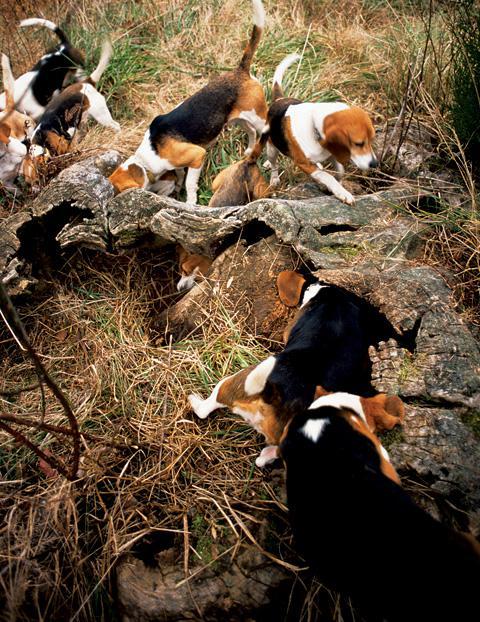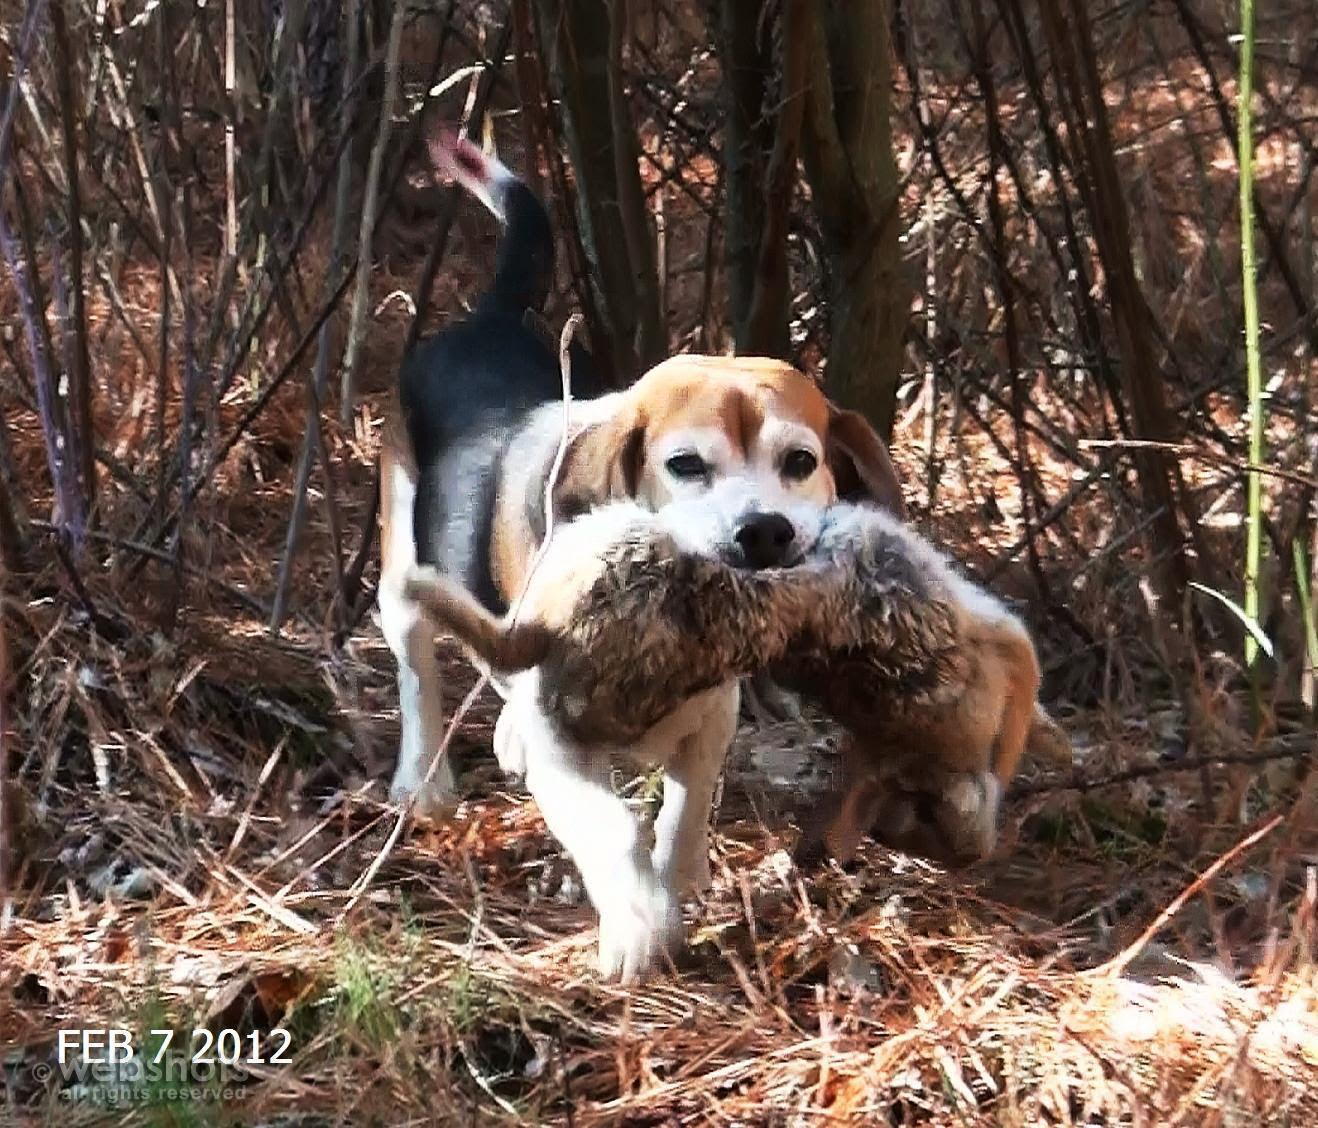The first image is the image on the left, the second image is the image on the right. For the images shown, is this caption "One dog is standing at attention and facing left." true? Answer yes or no. No. The first image is the image on the left, the second image is the image on the right. Examine the images to the left and right. Is the description "All images include a beagle in an outdoor setting, and at least one image shows multiple beagles behind a prey animal." accurate? Answer yes or no. No. 